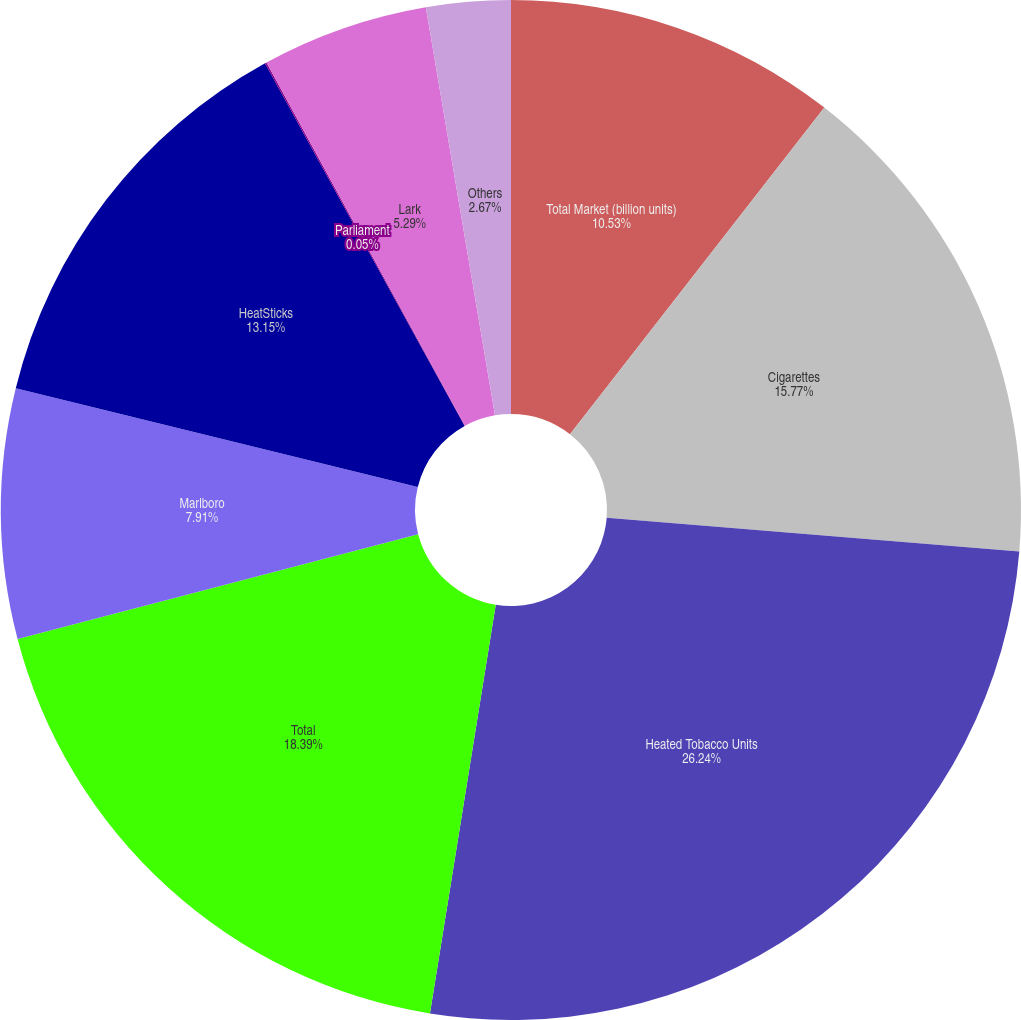Convert chart. <chart><loc_0><loc_0><loc_500><loc_500><pie_chart><fcel>Total Market (billion units)<fcel>Cigarettes<fcel>Heated Tobacco Units<fcel>Total<fcel>Marlboro<fcel>HeatSticks<fcel>Parliament<fcel>Lark<fcel>Others<nl><fcel>10.53%<fcel>15.77%<fcel>26.24%<fcel>18.39%<fcel>7.91%<fcel>13.15%<fcel>0.05%<fcel>5.29%<fcel>2.67%<nl></chart> 